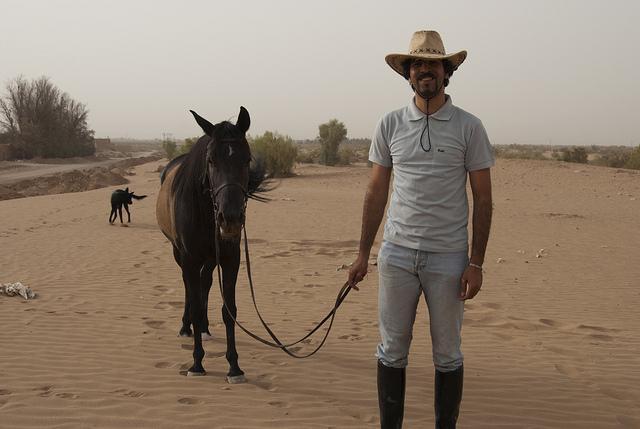How many different types of animals are shown?
Give a very brief answer. 2. 